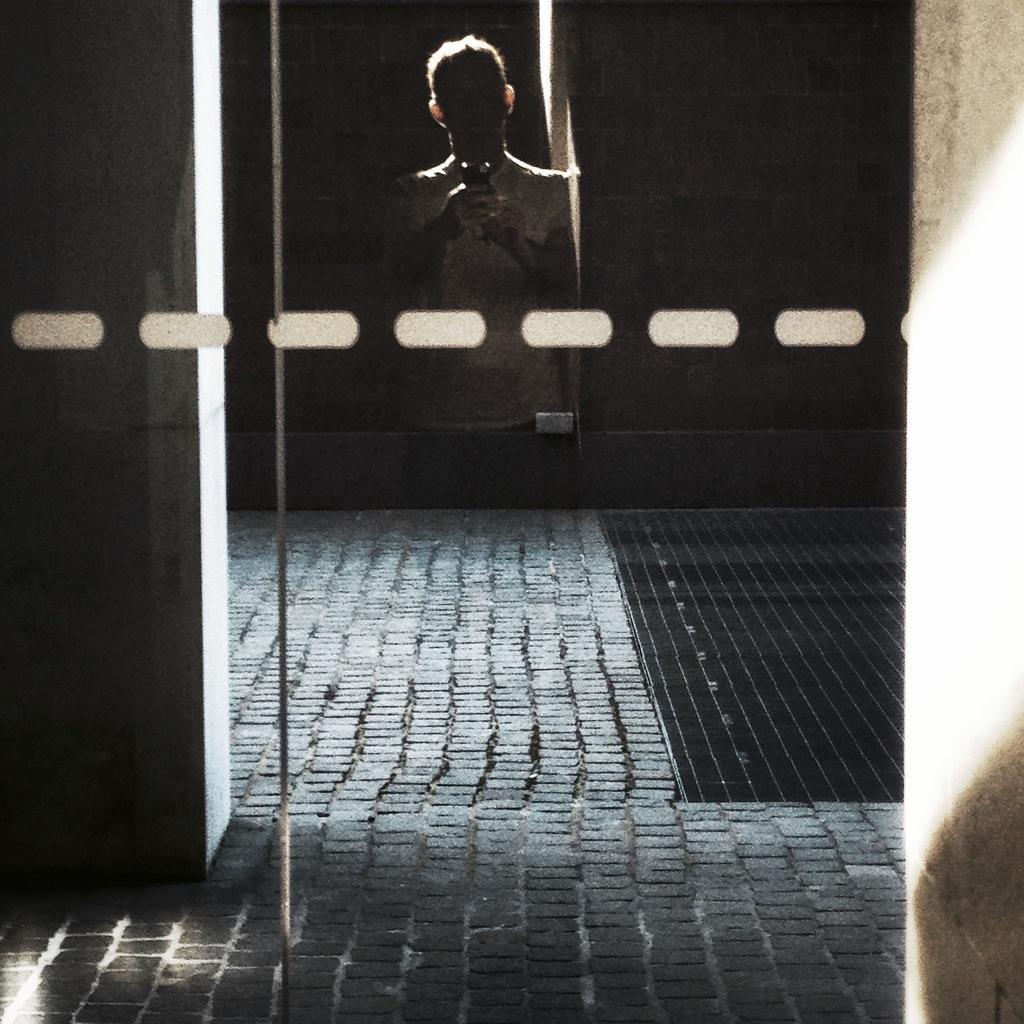In one or two sentences, can you explain what this image depicts? In this image we can see the reflection of a person on the glass, he is taking picture using cellphone, also we can see the wall, and the background is dark.  